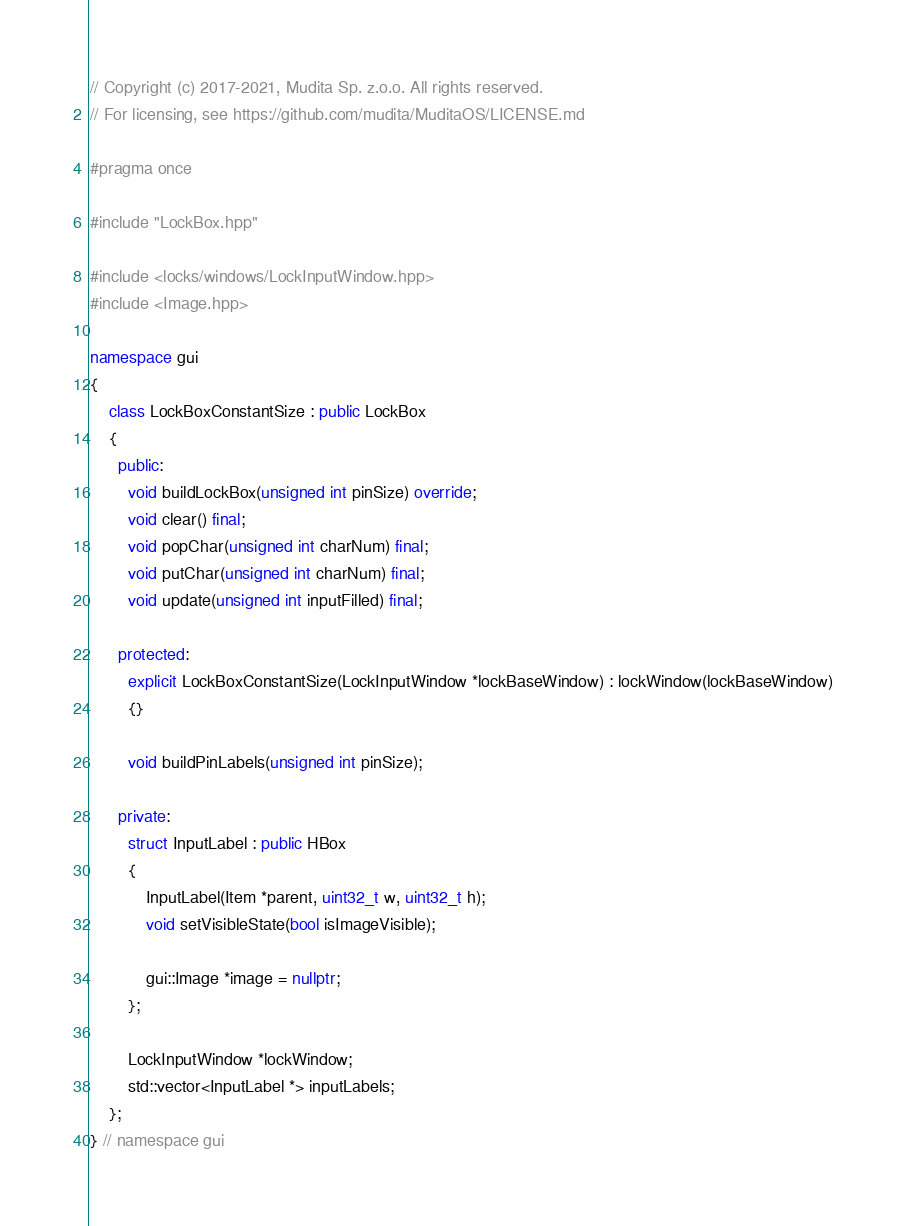<code> <loc_0><loc_0><loc_500><loc_500><_C++_>// Copyright (c) 2017-2021, Mudita Sp. z.o.o. All rights reserved.
// For licensing, see https://github.com/mudita/MuditaOS/LICENSE.md

#pragma once

#include "LockBox.hpp"

#include <locks/windows/LockInputWindow.hpp>
#include <Image.hpp>

namespace gui
{
    class LockBoxConstantSize : public LockBox
    {
      public:
        void buildLockBox(unsigned int pinSize) override;
        void clear() final;
        void popChar(unsigned int charNum) final;
        void putChar(unsigned int charNum) final;
        void update(unsigned int inputFilled) final;

      protected:
        explicit LockBoxConstantSize(LockInputWindow *lockBaseWindow) : lockWindow(lockBaseWindow)
        {}

        void buildPinLabels(unsigned int pinSize);

      private:
        struct InputLabel : public HBox
        {
            InputLabel(Item *parent, uint32_t w, uint32_t h);
            void setVisibleState(bool isImageVisible);

            gui::Image *image = nullptr;
        };

        LockInputWindow *lockWindow;
        std::vector<InputLabel *> inputLabels;
    };
} // namespace gui
</code> 